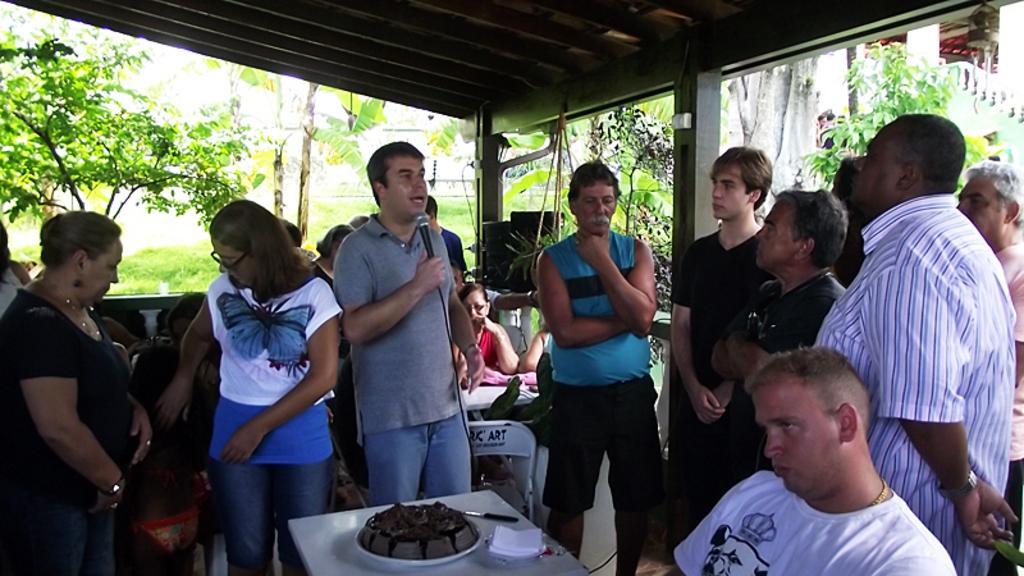Can you describe this image briefly? In this image we can see we can see people standing and some of them are sitting. The man standing in the center is holding a mic. At the bottom there is a table and we can see a cake, napkins and a knife placed on the table. In the background there are trees. At the top there is a roof. 